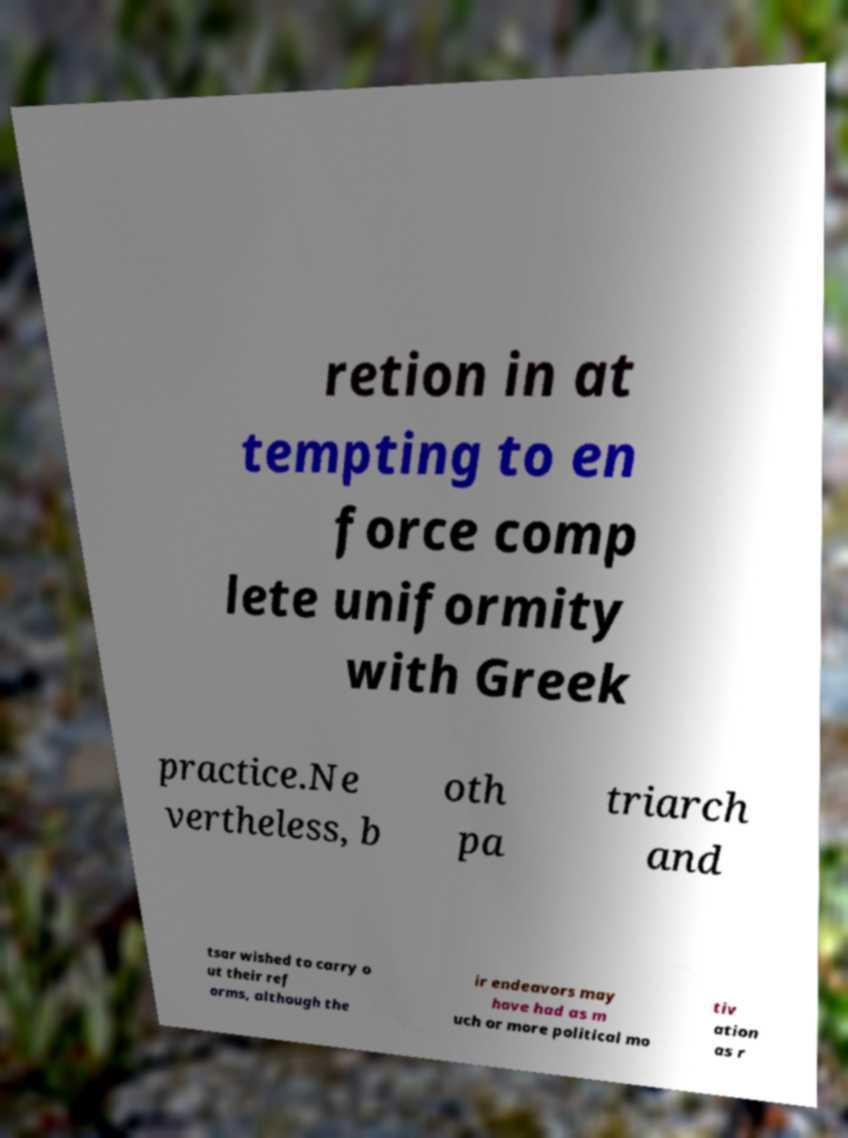I need the written content from this picture converted into text. Can you do that? retion in at tempting to en force comp lete uniformity with Greek practice.Ne vertheless, b oth pa triarch and tsar wished to carry o ut their ref orms, although the ir endeavors may have had as m uch or more political mo tiv ation as r 